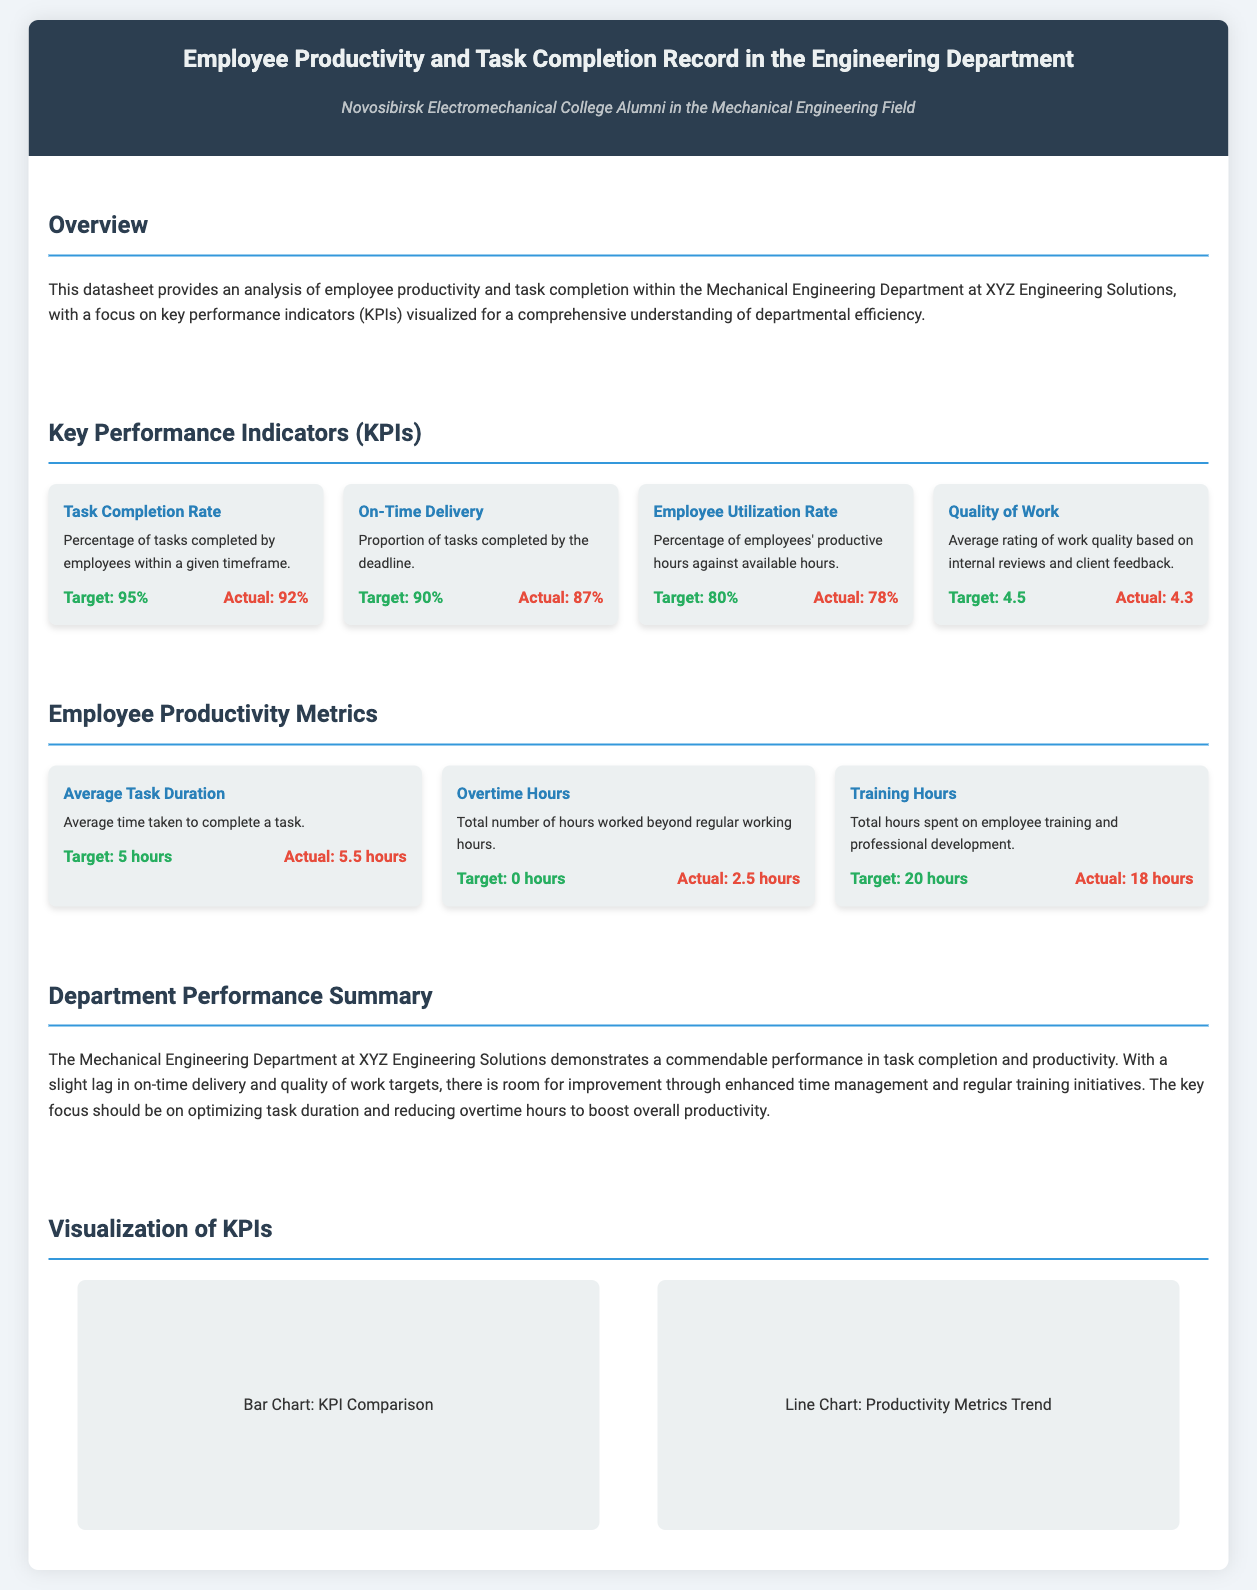What is the task completion rate target? The target for task completion rate is explicitly stated in the KPIs section of the document.
Answer: 95% What is the actual employee utilization rate? The actual employee utilization rate is specified as a KPI in the relevant section of the document.
Answer: 78% What is the average task duration target? The target time for average task duration is included in the employee productivity metrics.
Answer: 5 hours What is the actual quality of work rating? The actual quality of work rating can be found in the KPIs section of the document.
Answer: 4.3 What is the total number of overtime hours recorded? The total number of overtime hours is mentioned in the employee productivity metrics.
Answer: 2.5 hours What should be the focus for improvement in the department? The document suggests a focus area mentioned in the performance summary section.
Answer: Task duration and reducing overtime hours What metric shows a lag according to the document? A specific KPI is mentioned where actual performance is below the target in the overview.
Answer: On-Time Delivery What type of charts are included for KPI visualization? The visualizations for KPIs are briefly described in the visualization section of the document.
Answer: Bar Chart and Line Chart 